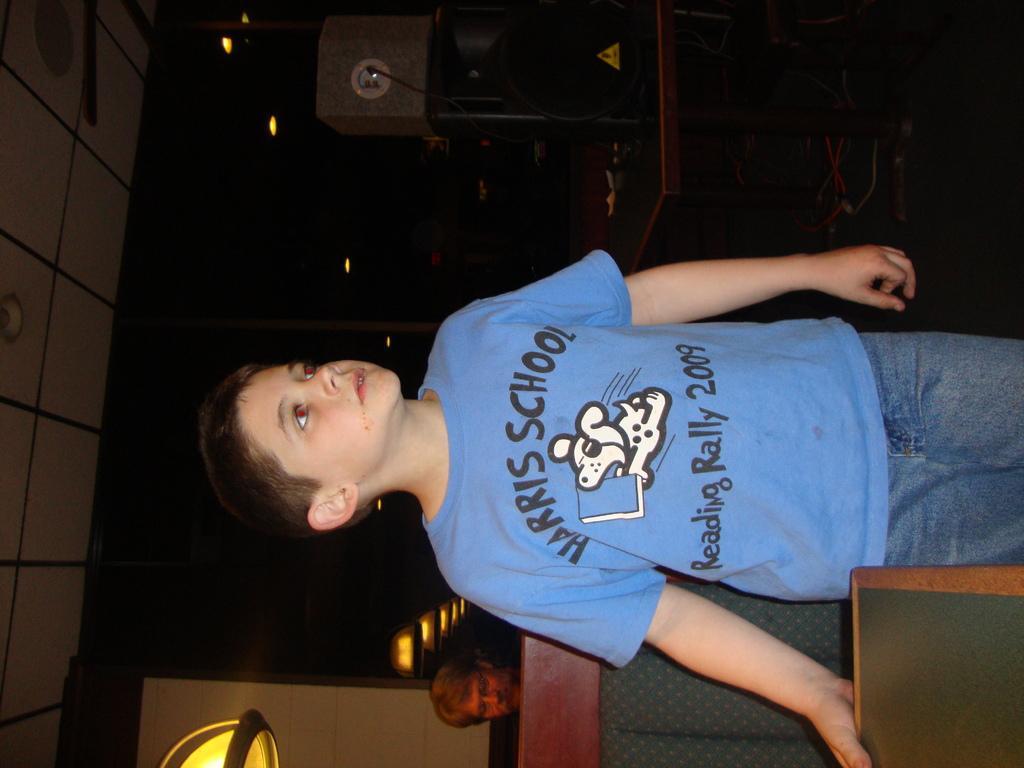Please provide a concise description of this image. This is the boy standing. He wore a T-shirt and trouser. This looks like a table. I think this is a desk. I can see a person. I think this is a mirror. I can see the reflection of the ceiling lights. At the top of the image, that looks like a machine, which is placed on the table. 